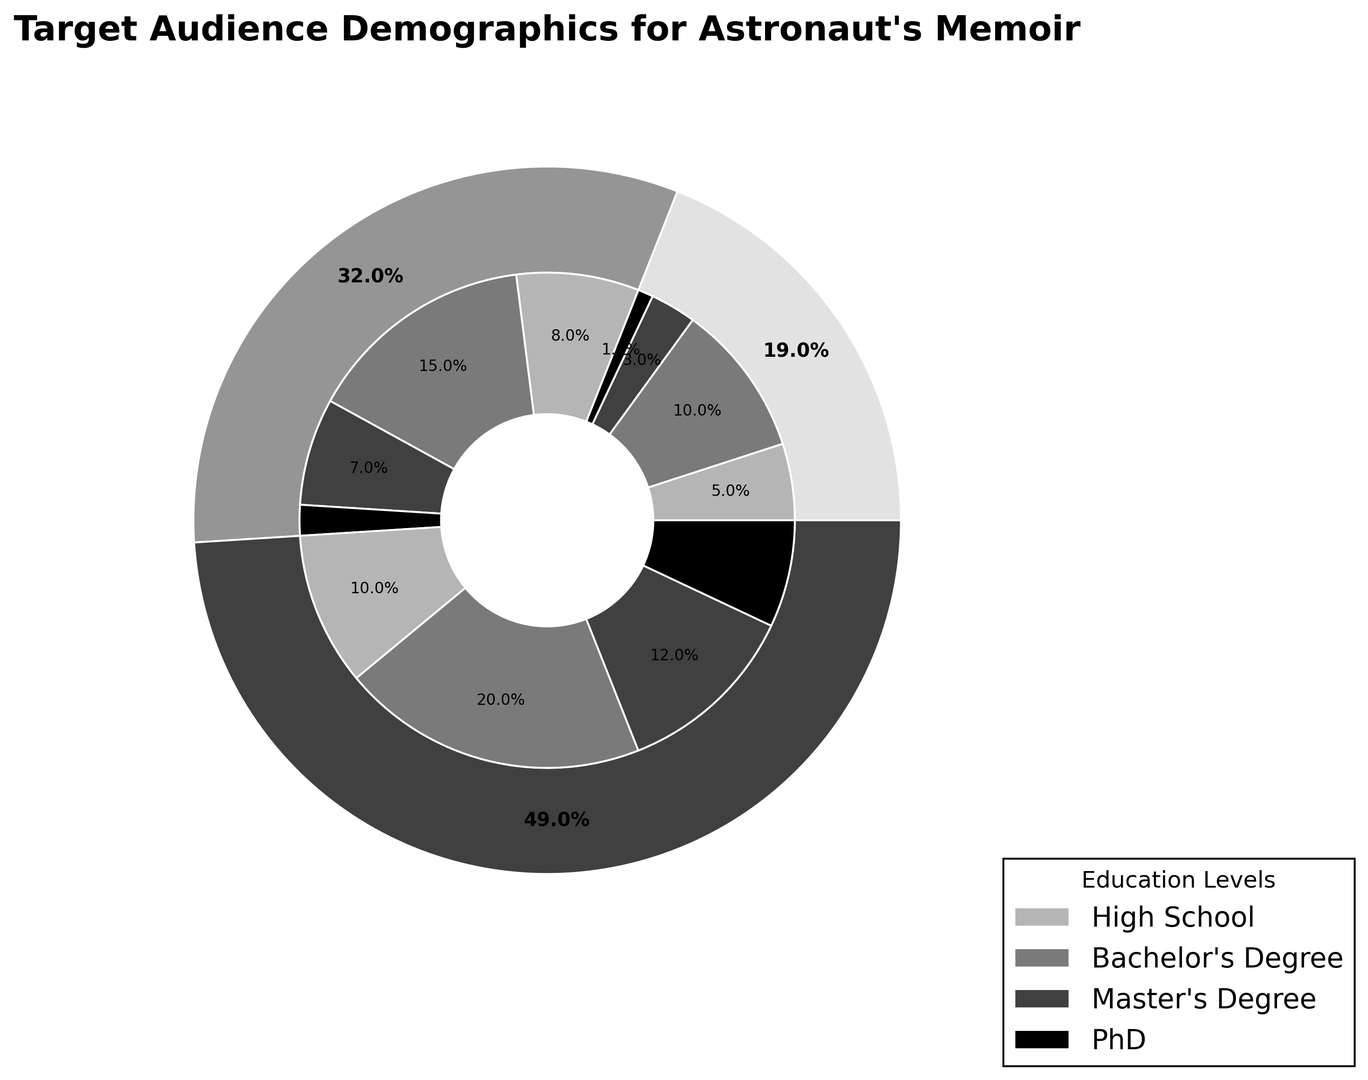What is the total percentage of the target audience aged 35-54 with a Bachelor's Degree or higher? To find this, sum the percentages of those aged 35-54 with a Bachelor's Degree, Master's Degree, and PhD. This is 15% + 7% + 2% = 24%.
Answer: 24% Which age group has the highest percentage of target audience with a Bachelor's Degree? Look at the inner ring segments labeled for Bachelor's Degree across different age groups. The group with the largest segment for Bachelor's Degree is the 55+ age group with 20%.
Answer: 55+ How does the percentage of the target audience with a High School education differ between the 18-34 and 55+ age groups? Subtract the High School percentages for the 18-34 age group from the 55+ age group. The percentages are 10% (55+) - 5% (18-34) = 5%.
Answer: 5% What is the combined percentage of the target audience aged 18-34 with a Bachelor's Degree and those aged 55+ with a Master's Degree? Sum the percentages for 18-34 Bachelor's Degree (10%) and 55+ Master's Degree (12%). This is 10% + 12% = 22%.
Answer: 22% Which education level within the 55+ age group makes up the largest segment? Check the inner ring segments for the 55+ age group and identify the one with the largest label. The Bachelor's Degree at 20% is the largest segment.
Answer: Bachelor's Degree Among those aged 35-54, which education level has the smallest percentage? Look at the percentages for each education level within the 35-54 age group. The smallest is PhD at 2%.
Answer: PhD What is the difference between the total percentages of the target audience aged 18-34 and 55+? Sum the percentages for each age group and subtract the two totals. For 18-34, it is 5% + 10% + 3% + 1% = 19%, and for 55+, it is 10% + 20% + 12% + 7% = 49%. The difference is 49% - 19% = 30%.
Answer: 30% Which age group has the smallest total percentage of the target audience? Compare the totals for each age group. The 18-34 age group has the smallest at 19%.
Answer: 18-34 